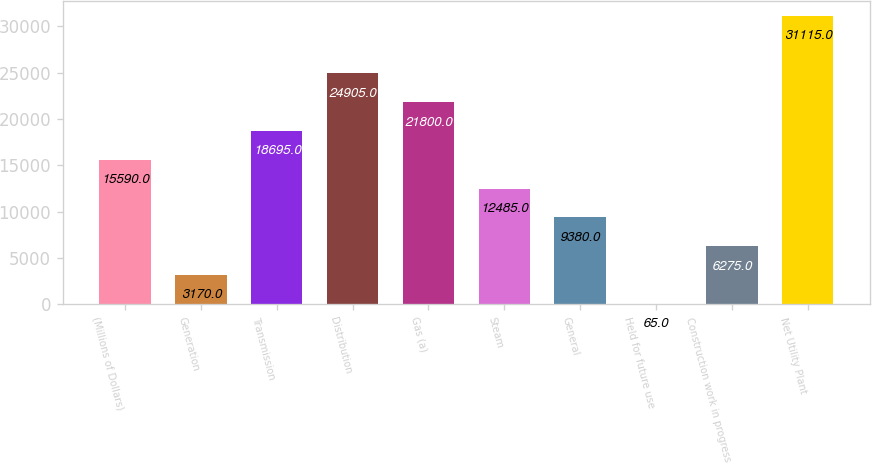Convert chart. <chart><loc_0><loc_0><loc_500><loc_500><bar_chart><fcel>(Millions of Dollars)<fcel>Generation<fcel>Transmission<fcel>Distribution<fcel>Gas (a)<fcel>Steam<fcel>General<fcel>Held for future use<fcel>Construction work in progress<fcel>Net Utility Plant<nl><fcel>15590<fcel>3170<fcel>18695<fcel>24905<fcel>21800<fcel>12485<fcel>9380<fcel>65<fcel>6275<fcel>31115<nl></chart> 